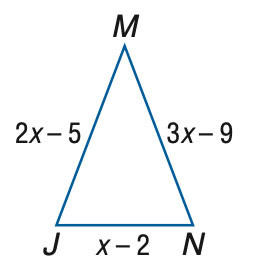Answer the mathemtical geometry problem and directly provide the correct option letter.
Question: Find J M if \triangle J M N is an isosceles triangle with J M \cong M N.
Choices: A: 2 B: 3 C: 4 D: 5 B 